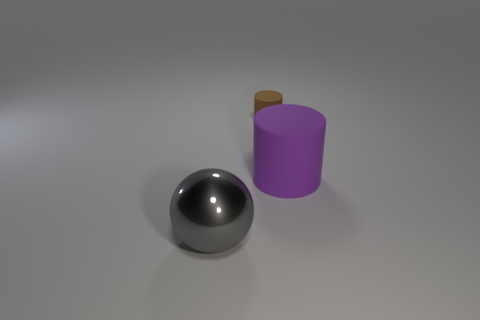Do the brown thing and the big purple matte thing have the same shape?
Give a very brief answer. Yes. There is a small thing that is the same shape as the large purple thing; what material is it?
Your answer should be very brief. Rubber. What number of large cylinders have the same color as the metallic ball?
Ensure brevity in your answer.  0. There is a brown cylinder that is made of the same material as the big purple object; what is its size?
Make the answer very short. Small. How many gray objects are either large spheres or rubber objects?
Your response must be concise. 1. How many large things are in front of the cylinder right of the tiny brown thing?
Make the answer very short. 1. Is the number of gray things that are behind the gray object greater than the number of gray shiny balls that are behind the large cylinder?
Keep it short and to the point. No. What is the material of the purple cylinder?
Your response must be concise. Rubber. Is there a purple thing that has the same size as the gray ball?
Your answer should be compact. Yes. There is a cylinder that is the same size as the shiny object; what is its material?
Provide a short and direct response. Rubber. 